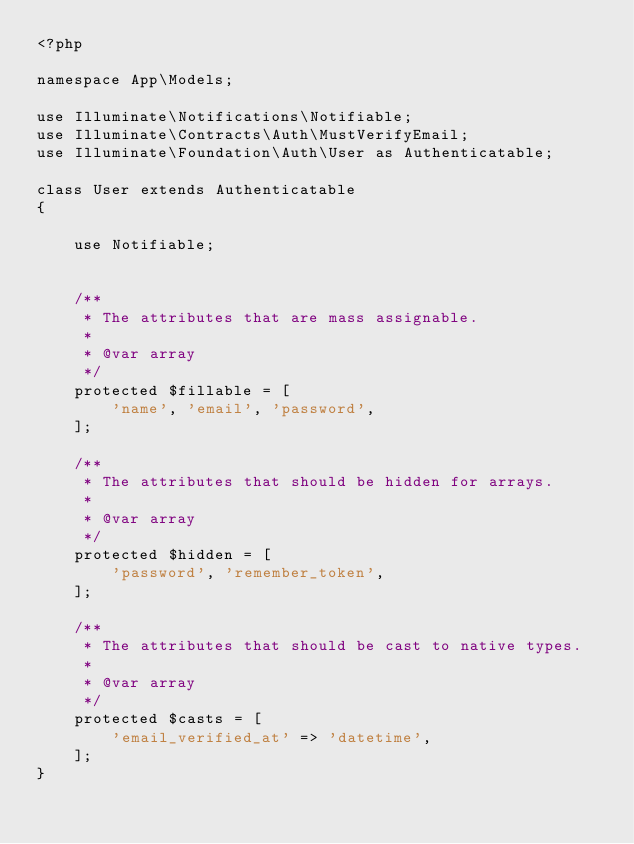Convert code to text. <code><loc_0><loc_0><loc_500><loc_500><_PHP_><?php

namespace App\Models;

use Illuminate\Notifications\Notifiable;
use Illuminate\Contracts\Auth\MustVerifyEmail;
use Illuminate\Foundation\Auth\User as Authenticatable;

class User extends Authenticatable
{

    use Notifiable;
    

    /**
     * The attributes that are mass assignable.
     *
     * @var array
     */
    protected $fillable = [
        'name', 'email', 'password',
    ];

    /**
     * The attributes that should be hidden for arrays.
     *
     * @var array
     */
    protected $hidden = [
        'password', 'remember_token',
    ];

    /**
     * The attributes that should be cast to native types.
     *
     * @var array
     */
    protected $casts = [
        'email_verified_at' => 'datetime',
    ];
}
</code> 